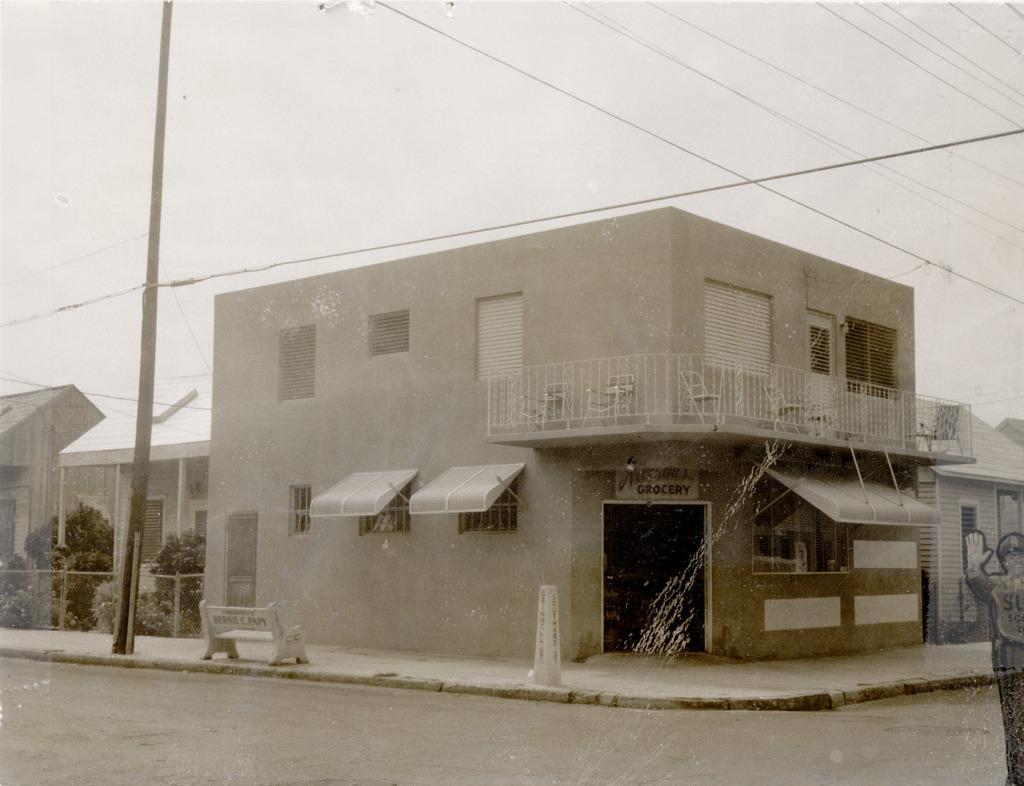Describe this image in one or two sentences. There is a building with windows, balcony and door. On the side of the building there is a sidewalk. On that there is a pole and bench. In the back there are trees, buildings and sky in the background. Also there is a road. 